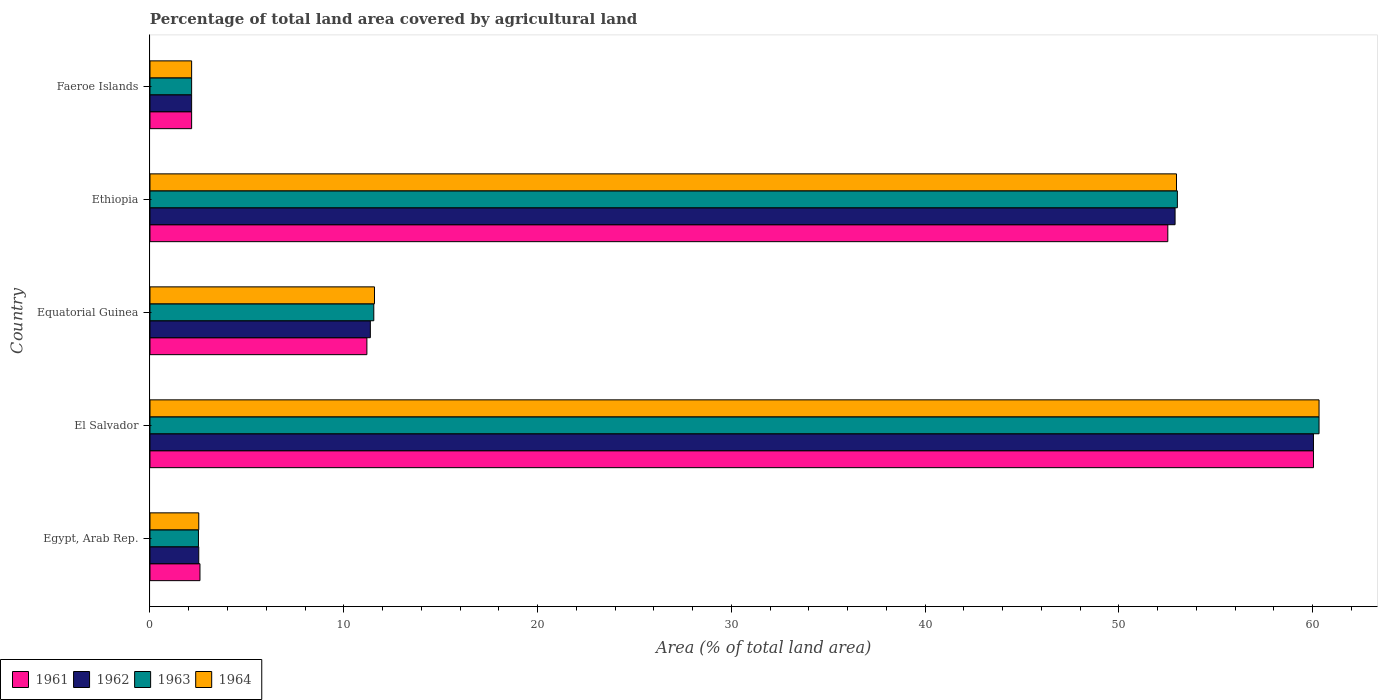How many groups of bars are there?
Keep it short and to the point. 5. Are the number of bars per tick equal to the number of legend labels?
Your answer should be very brief. Yes. Are the number of bars on each tick of the Y-axis equal?
Provide a succinct answer. Yes. How many bars are there on the 1st tick from the bottom?
Your answer should be compact. 4. What is the label of the 2nd group of bars from the top?
Keep it short and to the point. Ethiopia. In how many cases, is the number of bars for a given country not equal to the number of legend labels?
Your response must be concise. 0. What is the percentage of agricultural land in 1963 in Ethiopia?
Provide a short and direct response. 53.02. Across all countries, what is the maximum percentage of agricultural land in 1964?
Your response must be concise. 60.34. Across all countries, what is the minimum percentage of agricultural land in 1963?
Offer a terse response. 2.15. In which country was the percentage of agricultural land in 1961 maximum?
Provide a short and direct response. El Salvador. In which country was the percentage of agricultural land in 1963 minimum?
Your answer should be very brief. Faeroe Islands. What is the total percentage of agricultural land in 1964 in the graph?
Provide a short and direct response. 129.57. What is the difference between the percentage of agricultural land in 1962 in Equatorial Guinea and that in Ethiopia?
Offer a very short reply. -41.53. What is the difference between the percentage of agricultural land in 1964 in Ethiopia and the percentage of agricultural land in 1962 in Equatorial Guinea?
Give a very brief answer. 41.61. What is the average percentage of agricultural land in 1964 per country?
Your response must be concise. 25.91. What is the difference between the percentage of agricultural land in 1962 and percentage of agricultural land in 1961 in Faeroe Islands?
Offer a very short reply. 0. In how many countries, is the percentage of agricultural land in 1964 greater than 34 %?
Your response must be concise. 2. What is the ratio of the percentage of agricultural land in 1962 in Egypt, Arab Rep. to that in Faeroe Islands?
Offer a very short reply. 1.17. Is the percentage of agricultural land in 1964 in Equatorial Guinea less than that in Ethiopia?
Provide a succinct answer. Yes. What is the difference between the highest and the second highest percentage of agricultural land in 1961?
Your answer should be compact. 7.52. What is the difference between the highest and the lowest percentage of agricultural land in 1963?
Your answer should be very brief. 58.19. What does the 1st bar from the top in Ethiopia represents?
Ensure brevity in your answer.  1964. What does the 2nd bar from the bottom in Ethiopia represents?
Make the answer very short. 1962. How many bars are there?
Give a very brief answer. 20. Are all the bars in the graph horizontal?
Offer a terse response. Yes. How many countries are there in the graph?
Your response must be concise. 5. How many legend labels are there?
Ensure brevity in your answer.  4. How are the legend labels stacked?
Give a very brief answer. Horizontal. What is the title of the graph?
Give a very brief answer. Percentage of total land area covered by agricultural land. Does "1971" appear as one of the legend labels in the graph?
Keep it short and to the point. No. What is the label or title of the X-axis?
Your answer should be compact. Area (% of total land area). What is the Area (% of total land area) of 1961 in Egypt, Arab Rep.?
Keep it short and to the point. 2.58. What is the Area (% of total land area) in 1962 in Egypt, Arab Rep.?
Provide a succinct answer. 2.52. What is the Area (% of total land area) of 1963 in Egypt, Arab Rep.?
Provide a short and direct response. 2.5. What is the Area (% of total land area) of 1964 in Egypt, Arab Rep.?
Your response must be concise. 2.52. What is the Area (% of total land area) of 1961 in El Salvador?
Ensure brevity in your answer.  60.05. What is the Area (% of total land area) of 1962 in El Salvador?
Provide a succinct answer. 60.05. What is the Area (% of total land area) of 1963 in El Salvador?
Your response must be concise. 60.34. What is the Area (% of total land area) of 1964 in El Salvador?
Make the answer very short. 60.34. What is the Area (% of total land area) of 1961 in Equatorial Guinea?
Provide a succinct answer. 11.19. What is the Area (% of total land area) of 1962 in Equatorial Guinea?
Offer a terse response. 11.37. What is the Area (% of total land area) of 1963 in Equatorial Guinea?
Offer a very short reply. 11.55. What is the Area (% of total land area) of 1964 in Equatorial Guinea?
Offer a very short reply. 11.59. What is the Area (% of total land area) of 1961 in Ethiopia?
Offer a terse response. 52.53. What is the Area (% of total land area) of 1962 in Ethiopia?
Provide a succinct answer. 52.91. What is the Area (% of total land area) in 1963 in Ethiopia?
Offer a very short reply. 53.02. What is the Area (% of total land area) in 1964 in Ethiopia?
Offer a very short reply. 52.98. What is the Area (% of total land area) of 1961 in Faeroe Islands?
Your answer should be compact. 2.15. What is the Area (% of total land area) of 1962 in Faeroe Islands?
Keep it short and to the point. 2.15. What is the Area (% of total land area) in 1963 in Faeroe Islands?
Provide a short and direct response. 2.15. What is the Area (% of total land area) in 1964 in Faeroe Islands?
Provide a short and direct response. 2.15. Across all countries, what is the maximum Area (% of total land area) in 1961?
Give a very brief answer. 60.05. Across all countries, what is the maximum Area (% of total land area) of 1962?
Give a very brief answer. 60.05. Across all countries, what is the maximum Area (% of total land area) of 1963?
Your answer should be very brief. 60.34. Across all countries, what is the maximum Area (% of total land area) of 1964?
Your answer should be compact. 60.34. Across all countries, what is the minimum Area (% of total land area) of 1961?
Your response must be concise. 2.15. Across all countries, what is the minimum Area (% of total land area) of 1962?
Provide a short and direct response. 2.15. Across all countries, what is the minimum Area (% of total land area) in 1963?
Make the answer very short. 2.15. Across all countries, what is the minimum Area (% of total land area) of 1964?
Make the answer very short. 2.15. What is the total Area (% of total land area) in 1961 in the graph?
Provide a short and direct response. 128.5. What is the total Area (% of total land area) in 1962 in the graph?
Your response must be concise. 128.99. What is the total Area (% of total land area) in 1963 in the graph?
Your answer should be compact. 129.56. What is the total Area (% of total land area) in 1964 in the graph?
Offer a terse response. 129.57. What is the difference between the Area (% of total land area) in 1961 in Egypt, Arab Rep. and that in El Salvador?
Your answer should be compact. -57.47. What is the difference between the Area (% of total land area) of 1962 in Egypt, Arab Rep. and that in El Salvador?
Provide a succinct answer. -57.53. What is the difference between the Area (% of total land area) of 1963 in Egypt, Arab Rep. and that in El Salvador?
Offer a very short reply. -57.83. What is the difference between the Area (% of total land area) in 1964 in Egypt, Arab Rep. and that in El Salvador?
Offer a terse response. -57.82. What is the difference between the Area (% of total land area) in 1961 in Egypt, Arab Rep. and that in Equatorial Guinea?
Your response must be concise. -8.61. What is the difference between the Area (% of total land area) of 1962 in Egypt, Arab Rep. and that in Equatorial Guinea?
Your response must be concise. -8.86. What is the difference between the Area (% of total land area) in 1963 in Egypt, Arab Rep. and that in Equatorial Guinea?
Your response must be concise. -9.05. What is the difference between the Area (% of total land area) in 1964 in Egypt, Arab Rep. and that in Equatorial Guinea?
Your response must be concise. -9.07. What is the difference between the Area (% of total land area) of 1961 in Egypt, Arab Rep. and that in Ethiopia?
Your answer should be compact. -49.95. What is the difference between the Area (% of total land area) of 1962 in Egypt, Arab Rep. and that in Ethiopia?
Ensure brevity in your answer.  -50.39. What is the difference between the Area (% of total land area) in 1963 in Egypt, Arab Rep. and that in Ethiopia?
Keep it short and to the point. -50.52. What is the difference between the Area (% of total land area) of 1964 in Egypt, Arab Rep. and that in Ethiopia?
Keep it short and to the point. -50.46. What is the difference between the Area (% of total land area) in 1961 in Egypt, Arab Rep. and that in Faeroe Islands?
Give a very brief answer. 0.43. What is the difference between the Area (% of total land area) in 1962 in Egypt, Arab Rep. and that in Faeroe Islands?
Keep it short and to the point. 0.37. What is the difference between the Area (% of total land area) of 1963 in Egypt, Arab Rep. and that in Faeroe Islands?
Your answer should be very brief. 0.35. What is the difference between the Area (% of total land area) in 1964 in Egypt, Arab Rep. and that in Faeroe Islands?
Keep it short and to the point. 0.37. What is the difference between the Area (% of total land area) in 1961 in El Salvador and that in Equatorial Guinea?
Ensure brevity in your answer.  48.85. What is the difference between the Area (% of total land area) of 1962 in El Salvador and that in Equatorial Guinea?
Ensure brevity in your answer.  48.68. What is the difference between the Area (% of total land area) of 1963 in El Salvador and that in Equatorial Guinea?
Your answer should be very brief. 48.78. What is the difference between the Area (% of total land area) in 1964 in El Salvador and that in Equatorial Guinea?
Keep it short and to the point. 48.75. What is the difference between the Area (% of total land area) in 1961 in El Salvador and that in Ethiopia?
Your response must be concise. 7.52. What is the difference between the Area (% of total land area) of 1962 in El Salvador and that in Ethiopia?
Provide a short and direct response. 7.14. What is the difference between the Area (% of total land area) of 1963 in El Salvador and that in Ethiopia?
Provide a succinct answer. 7.31. What is the difference between the Area (% of total land area) in 1964 in El Salvador and that in Ethiopia?
Give a very brief answer. 7.36. What is the difference between the Area (% of total land area) of 1961 in El Salvador and that in Faeroe Islands?
Your answer should be compact. 57.9. What is the difference between the Area (% of total land area) in 1962 in El Salvador and that in Faeroe Islands?
Make the answer very short. 57.9. What is the difference between the Area (% of total land area) in 1963 in El Salvador and that in Faeroe Islands?
Keep it short and to the point. 58.19. What is the difference between the Area (% of total land area) of 1964 in El Salvador and that in Faeroe Islands?
Offer a very short reply. 58.19. What is the difference between the Area (% of total land area) of 1961 in Equatorial Guinea and that in Ethiopia?
Make the answer very short. -41.34. What is the difference between the Area (% of total land area) of 1962 in Equatorial Guinea and that in Ethiopia?
Provide a short and direct response. -41.53. What is the difference between the Area (% of total land area) of 1963 in Equatorial Guinea and that in Ethiopia?
Provide a succinct answer. -41.47. What is the difference between the Area (% of total land area) in 1964 in Equatorial Guinea and that in Ethiopia?
Your answer should be very brief. -41.39. What is the difference between the Area (% of total land area) of 1961 in Equatorial Guinea and that in Faeroe Islands?
Provide a short and direct response. 9.05. What is the difference between the Area (% of total land area) in 1962 in Equatorial Guinea and that in Faeroe Islands?
Provide a short and direct response. 9.22. What is the difference between the Area (% of total land area) of 1963 in Equatorial Guinea and that in Faeroe Islands?
Offer a very short reply. 9.4. What is the difference between the Area (% of total land area) in 1964 in Equatorial Guinea and that in Faeroe Islands?
Ensure brevity in your answer.  9.44. What is the difference between the Area (% of total land area) in 1961 in Ethiopia and that in Faeroe Islands?
Your answer should be very brief. 50.38. What is the difference between the Area (% of total land area) of 1962 in Ethiopia and that in Faeroe Islands?
Give a very brief answer. 50.76. What is the difference between the Area (% of total land area) in 1963 in Ethiopia and that in Faeroe Islands?
Your answer should be very brief. 50.88. What is the difference between the Area (% of total land area) in 1964 in Ethiopia and that in Faeroe Islands?
Provide a succinct answer. 50.83. What is the difference between the Area (% of total land area) of 1961 in Egypt, Arab Rep. and the Area (% of total land area) of 1962 in El Salvador?
Give a very brief answer. -57.47. What is the difference between the Area (% of total land area) of 1961 in Egypt, Arab Rep. and the Area (% of total land area) of 1963 in El Salvador?
Offer a terse response. -57.76. What is the difference between the Area (% of total land area) of 1961 in Egypt, Arab Rep. and the Area (% of total land area) of 1964 in El Salvador?
Your response must be concise. -57.76. What is the difference between the Area (% of total land area) in 1962 in Egypt, Arab Rep. and the Area (% of total land area) in 1963 in El Salvador?
Your answer should be very brief. -57.82. What is the difference between the Area (% of total land area) of 1962 in Egypt, Arab Rep. and the Area (% of total land area) of 1964 in El Salvador?
Offer a terse response. -57.82. What is the difference between the Area (% of total land area) of 1963 in Egypt, Arab Rep. and the Area (% of total land area) of 1964 in El Salvador?
Keep it short and to the point. -57.83. What is the difference between the Area (% of total land area) in 1961 in Egypt, Arab Rep. and the Area (% of total land area) in 1962 in Equatorial Guinea?
Your answer should be very brief. -8.79. What is the difference between the Area (% of total land area) in 1961 in Egypt, Arab Rep. and the Area (% of total land area) in 1963 in Equatorial Guinea?
Your response must be concise. -8.97. What is the difference between the Area (% of total land area) in 1961 in Egypt, Arab Rep. and the Area (% of total land area) in 1964 in Equatorial Guinea?
Keep it short and to the point. -9.01. What is the difference between the Area (% of total land area) of 1962 in Egypt, Arab Rep. and the Area (% of total land area) of 1963 in Equatorial Guinea?
Keep it short and to the point. -9.03. What is the difference between the Area (% of total land area) of 1962 in Egypt, Arab Rep. and the Area (% of total land area) of 1964 in Equatorial Guinea?
Your answer should be compact. -9.07. What is the difference between the Area (% of total land area) in 1963 in Egypt, Arab Rep. and the Area (% of total land area) in 1964 in Equatorial Guinea?
Your response must be concise. -9.09. What is the difference between the Area (% of total land area) in 1961 in Egypt, Arab Rep. and the Area (% of total land area) in 1962 in Ethiopia?
Give a very brief answer. -50.33. What is the difference between the Area (% of total land area) in 1961 in Egypt, Arab Rep. and the Area (% of total land area) in 1963 in Ethiopia?
Make the answer very short. -50.44. What is the difference between the Area (% of total land area) of 1961 in Egypt, Arab Rep. and the Area (% of total land area) of 1964 in Ethiopia?
Offer a terse response. -50.4. What is the difference between the Area (% of total land area) in 1962 in Egypt, Arab Rep. and the Area (% of total land area) in 1963 in Ethiopia?
Ensure brevity in your answer.  -50.51. What is the difference between the Area (% of total land area) in 1962 in Egypt, Arab Rep. and the Area (% of total land area) in 1964 in Ethiopia?
Provide a succinct answer. -50.46. What is the difference between the Area (% of total land area) in 1963 in Egypt, Arab Rep. and the Area (% of total land area) in 1964 in Ethiopia?
Provide a succinct answer. -50.48. What is the difference between the Area (% of total land area) in 1961 in Egypt, Arab Rep. and the Area (% of total land area) in 1962 in Faeroe Islands?
Your response must be concise. 0.43. What is the difference between the Area (% of total land area) of 1961 in Egypt, Arab Rep. and the Area (% of total land area) of 1963 in Faeroe Islands?
Give a very brief answer. 0.43. What is the difference between the Area (% of total land area) in 1961 in Egypt, Arab Rep. and the Area (% of total land area) in 1964 in Faeroe Islands?
Keep it short and to the point. 0.43. What is the difference between the Area (% of total land area) of 1962 in Egypt, Arab Rep. and the Area (% of total land area) of 1963 in Faeroe Islands?
Make the answer very short. 0.37. What is the difference between the Area (% of total land area) in 1962 in Egypt, Arab Rep. and the Area (% of total land area) in 1964 in Faeroe Islands?
Your response must be concise. 0.37. What is the difference between the Area (% of total land area) of 1963 in Egypt, Arab Rep. and the Area (% of total land area) of 1964 in Faeroe Islands?
Ensure brevity in your answer.  0.35. What is the difference between the Area (% of total land area) in 1961 in El Salvador and the Area (% of total land area) in 1962 in Equatorial Guinea?
Provide a succinct answer. 48.68. What is the difference between the Area (% of total land area) in 1961 in El Salvador and the Area (% of total land area) in 1963 in Equatorial Guinea?
Ensure brevity in your answer.  48.5. What is the difference between the Area (% of total land area) in 1961 in El Salvador and the Area (% of total land area) in 1964 in Equatorial Guinea?
Keep it short and to the point. 48.46. What is the difference between the Area (% of total land area) of 1962 in El Salvador and the Area (% of total land area) of 1963 in Equatorial Guinea?
Make the answer very short. 48.5. What is the difference between the Area (% of total land area) in 1962 in El Salvador and the Area (% of total land area) in 1964 in Equatorial Guinea?
Your answer should be compact. 48.46. What is the difference between the Area (% of total land area) of 1963 in El Salvador and the Area (% of total land area) of 1964 in Equatorial Guinea?
Make the answer very short. 48.75. What is the difference between the Area (% of total land area) of 1961 in El Salvador and the Area (% of total land area) of 1962 in Ethiopia?
Offer a very short reply. 7.14. What is the difference between the Area (% of total land area) of 1961 in El Salvador and the Area (% of total land area) of 1963 in Ethiopia?
Keep it short and to the point. 7.02. What is the difference between the Area (% of total land area) in 1961 in El Salvador and the Area (% of total land area) in 1964 in Ethiopia?
Give a very brief answer. 7.07. What is the difference between the Area (% of total land area) of 1962 in El Salvador and the Area (% of total land area) of 1963 in Ethiopia?
Offer a terse response. 7.02. What is the difference between the Area (% of total land area) of 1962 in El Salvador and the Area (% of total land area) of 1964 in Ethiopia?
Make the answer very short. 7.07. What is the difference between the Area (% of total land area) in 1963 in El Salvador and the Area (% of total land area) in 1964 in Ethiopia?
Your response must be concise. 7.36. What is the difference between the Area (% of total land area) in 1961 in El Salvador and the Area (% of total land area) in 1962 in Faeroe Islands?
Provide a short and direct response. 57.9. What is the difference between the Area (% of total land area) in 1961 in El Salvador and the Area (% of total land area) in 1963 in Faeroe Islands?
Your answer should be compact. 57.9. What is the difference between the Area (% of total land area) of 1961 in El Salvador and the Area (% of total land area) of 1964 in Faeroe Islands?
Provide a short and direct response. 57.9. What is the difference between the Area (% of total land area) of 1962 in El Salvador and the Area (% of total land area) of 1963 in Faeroe Islands?
Offer a very short reply. 57.9. What is the difference between the Area (% of total land area) of 1962 in El Salvador and the Area (% of total land area) of 1964 in Faeroe Islands?
Your answer should be compact. 57.9. What is the difference between the Area (% of total land area) in 1963 in El Salvador and the Area (% of total land area) in 1964 in Faeroe Islands?
Ensure brevity in your answer.  58.19. What is the difference between the Area (% of total land area) in 1961 in Equatorial Guinea and the Area (% of total land area) in 1962 in Ethiopia?
Provide a succinct answer. -41.71. What is the difference between the Area (% of total land area) of 1961 in Equatorial Guinea and the Area (% of total land area) of 1963 in Ethiopia?
Give a very brief answer. -41.83. What is the difference between the Area (% of total land area) of 1961 in Equatorial Guinea and the Area (% of total land area) of 1964 in Ethiopia?
Offer a terse response. -41.78. What is the difference between the Area (% of total land area) of 1962 in Equatorial Guinea and the Area (% of total land area) of 1963 in Ethiopia?
Offer a very short reply. -41.65. What is the difference between the Area (% of total land area) of 1962 in Equatorial Guinea and the Area (% of total land area) of 1964 in Ethiopia?
Your answer should be very brief. -41.61. What is the difference between the Area (% of total land area) in 1963 in Equatorial Guinea and the Area (% of total land area) in 1964 in Ethiopia?
Provide a short and direct response. -41.43. What is the difference between the Area (% of total land area) in 1961 in Equatorial Guinea and the Area (% of total land area) in 1962 in Faeroe Islands?
Your answer should be very brief. 9.05. What is the difference between the Area (% of total land area) in 1961 in Equatorial Guinea and the Area (% of total land area) in 1963 in Faeroe Islands?
Your response must be concise. 9.05. What is the difference between the Area (% of total land area) of 1961 in Equatorial Guinea and the Area (% of total land area) of 1964 in Faeroe Islands?
Make the answer very short. 9.05. What is the difference between the Area (% of total land area) of 1962 in Equatorial Guinea and the Area (% of total land area) of 1963 in Faeroe Islands?
Offer a terse response. 9.22. What is the difference between the Area (% of total land area) in 1962 in Equatorial Guinea and the Area (% of total land area) in 1964 in Faeroe Islands?
Your answer should be compact. 9.22. What is the difference between the Area (% of total land area) of 1963 in Equatorial Guinea and the Area (% of total land area) of 1964 in Faeroe Islands?
Make the answer very short. 9.4. What is the difference between the Area (% of total land area) of 1961 in Ethiopia and the Area (% of total land area) of 1962 in Faeroe Islands?
Your response must be concise. 50.38. What is the difference between the Area (% of total land area) in 1961 in Ethiopia and the Area (% of total land area) in 1963 in Faeroe Islands?
Your answer should be compact. 50.38. What is the difference between the Area (% of total land area) of 1961 in Ethiopia and the Area (% of total land area) of 1964 in Faeroe Islands?
Give a very brief answer. 50.38. What is the difference between the Area (% of total land area) of 1962 in Ethiopia and the Area (% of total land area) of 1963 in Faeroe Islands?
Offer a terse response. 50.76. What is the difference between the Area (% of total land area) in 1962 in Ethiopia and the Area (% of total land area) in 1964 in Faeroe Islands?
Your response must be concise. 50.76. What is the difference between the Area (% of total land area) in 1963 in Ethiopia and the Area (% of total land area) in 1964 in Faeroe Islands?
Give a very brief answer. 50.88. What is the average Area (% of total land area) in 1961 per country?
Your answer should be compact. 25.7. What is the average Area (% of total land area) in 1962 per country?
Ensure brevity in your answer.  25.8. What is the average Area (% of total land area) of 1963 per country?
Your answer should be very brief. 25.91. What is the average Area (% of total land area) of 1964 per country?
Keep it short and to the point. 25.91. What is the difference between the Area (% of total land area) of 1961 and Area (% of total land area) of 1962 in Egypt, Arab Rep.?
Ensure brevity in your answer.  0.06. What is the difference between the Area (% of total land area) in 1961 and Area (% of total land area) in 1963 in Egypt, Arab Rep.?
Keep it short and to the point. 0.08. What is the difference between the Area (% of total land area) of 1961 and Area (% of total land area) of 1964 in Egypt, Arab Rep.?
Ensure brevity in your answer.  0.06. What is the difference between the Area (% of total land area) in 1962 and Area (% of total land area) in 1963 in Egypt, Arab Rep.?
Your response must be concise. 0.02. What is the difference between the Area (% of total land area) in 1962 and Area (% of total land area) in 1964 in Egypt, Arab Rep.?
Offer a very short reply. -0. What is the difference between the Area (% of total land area) of 1963 and Area (% of total land area) of 1964 in Egypt, Arab Rep.?
Your answer should be compact. -0.02. What is the difference between the Area (% of total land area) of 1961 and Area (% of total land area) of 1963 in El Salvador?
Your response must be concise. -0.29. What is the difference between the Area (% of total land area) in 1961 and Area (% of total land area) in 1964 in El Salvador?
Your response must be concise. -0.29. What is the difference between the Area (% of total land area) of 1962 and Area (% of total land area) of 1963 in El Salvador?
Provide a short and direct response. -0.29. What is the difference between the Area (% of total land area) in 1962 and Area (% of total land area) in 1964 in El Salvador?
Make the answer very short. -0.29. What is the difference between the Area (% of total land area) of 1963 and Area (% of total land area) of 1964 in El Salvador?
Keep it short and to the point. 0. What is the difference between the Area (% of total land area) in 1961 and Area (% of total land area) in 1962 in Equatorial Guinea?
Your response must be concise. -0.18. What is the difference between the Area (% of total land area) in 1961 and Area (% of total land area) in 1963 in Equatorial Guinea?
Keep it short and to the point. -0.36. What is the difference between the Area (% of total land area) in 1961 and Area (% of total land area) in 1964 in Equatorial Guinea?
Provide a short and direct response. -0.39. What is the difference between the Area (% of total land area) in 1962 and Area (% of total land area) in 1963 in Equatorial Guinea?
Give a very brief answer. -0.18. What is the difference between the Area (% of total land area) in 1962 and Area (% of total land area) in 1964 in Equatorial Guinea?
Make the answer very short. -0.21. What is the difference between the Area (% of total land area) of 1963 and Area (% of total land area) of 1964 in Equatorial Guinea?
Offer a very short reply. -0.04. What is the difference between the Area (% of total land area) of 1961 and Area (% of total land area) of 1962 in Ethiopia?
Your answer should be compact. -0.38. What is the difference between the Area (% of total land area) in 1961 and Area (% of total land area) in 1963 in Ethiopia?
Offer a very short reply. -0.49. What is the difference between the Area (% of total land area) of 1961 and Area (% of total land area) of 1964 in Ethiopia?
Offer a very short reply. -0.45. What is the difference between the Area (% of total land area) in 1962 and Area (% of total land area) in 1963 in Ethiopia?
Ensure brevity in your answer.  -0.12. What is the difference between the Area (% of total land area) in 1962 and Area (% of total land area) in 1964 in Ethiopia?
Provide a succinct answer. -0.07. What is the difference between the Area (% of total land area) in 1963 and Area (% of total land area) in 1964 in Ethiopia?
Ensure brevity in your answer.  0.05. What is the difference between the Area (% of total land area) in 1961 and Area (% of total land area) in 1963 in Faeroe Islands?
Offer a terse response. 0. What is the difference between the Area (% of total land area) in 1962 and Area (% of total land area) in 1964 in Faeroe Islands?
Your response must be concise. 0. What is the ratio of the Area (% of total land area) in 1961 in Egypt, Arab Rep. to that in El Salvador?
Your response must be concise. 0.04. What is the ratio of the Area (% of total land area) of 1962 in Egypt, Arab Rep. to that in El Salvador?
Your answer should be compact. 0.04. What is the ratio of the Area (% of total land area) of 1963 in Egypt, Arab Rep. to that in El Salvador?
Offer a very short reply. 0.04. What is the ratio of the Area (% of total land area) in 1964 in Egypt, Arab Rep. to that in El Salvador?
Offer a very short reply. 0.04. What is the ratio of the Area (% of total land area) in 1961 in Egypt, Arab Rep. to that in Equatorial Guinea?
Offer a terse response. 0.23. What is the ratio of the Area (% of total land area) in 1962 in Egypt, Arab Rep. to that in Equatorial Guinea?
Offer a very short reply. 0.22. What is the ratio of the Area (% of total land area) of 1963 in Egypt, Arab Rep. to that in Equatorial Guinea?
Ensure brevity in your answer.  0.22. What is the ratio of the Area (% of total land area) in 1964 in Egypt, Arab Rep. to that in Equatorial Guinea?
Provide a short and direct response. 0.22. What is the ratio of the Area (% of total land area) of 1961 in Egypt, Arab Rep. to that in Ethiopia?
Provide a succinct answer. 0.05. What is the ratio of the Area (% of total land area) in 1962 in Egypt, Arab Rep. to that in Ethiopia?
Keep it short and to the point. 0.05. What is the ratio of the Area (% of total land area) in 1963 in Egypt, Arab Rep. to that in Ethiopia?
Your answer should be compact. 0.05. What is the ratio of the Area (% of total land area) of 1964 in Egypt, Arab Rep. to that in Ethiopia?
Offer a terse response. 0.05. What is the ratio of the Area (% of total land area) of 1961 in Egypt, Arab Rep. to that in Faeroe Islands?
Ensure brevity in your answer.  1.2. What is the ratio of the Area (% of total land area) of 1962 in Egypt, Arab Rep. to that in Faeroe Islands?
Your answer should be very brief. 1.17. What is the ratio of the Area (% of total land area) in 1963 in Egypt, Arab Rep. to that in Faeroe Islands?
Keep it short and to the point. 1.16. What is the ratio of the Area (% of total land area) in 1964 in Egypt, Arab Rep. to that in Faeroe Islands?
Offer a very short reply. 1.17. What is the ratio of the Area (% of total land area) in 1961 in El Salvador to that in Equatorial Guinea?
Your answer should be compact. 5.36. What is the ratio of the Area (% of total land area) in 1962 in El Salvador to that in Equatorial Guinea?
Make the answer very short. 5.28. What is the ratio of the Area (% of total land area) of 1963 in El Salvador to that in Equatorial Guinea?
Make the answer very short. 5.22. What is the ratio of the Area (% of total land area) in 1964 in El Salvador to that in Equatorial Guinea?
Give a very brief answer. 5.21. What is the ratio of the Area (% of total land area) in 1961 in El Salvador to that in Ethiopia?
Offer a very short reply. 1.14. What is the ratio of the Area (% of total land area) of 1962 in El Salvador to that in Ethiopia?
Your answer should be compact. 1.14. What is the ratio of the Area (% of total land area) of 1963 in El Salvador to that in Ethiopia?
Your response must be concise. 1.14. What is the ratio of the Area (% of total land area) in 1964 in El Salvador to that in Ethiopia?
Offer a very short reply. 1.14. What is the ratio of the Area (% of total land area) in 1961 in El Salvador to that in Faeroe Islands?
Ensure brevity in your answer.  27.94. What is the ratio of the Area (% of total land area) in 1962 in El Salvador to that in Faeroe Islands?
Offer a very short reply. 27.94. What is the ratio of the Area (% of total land area) in 1963 in El Salvador to that in Faeroe Islands?
Your response must be concise. 28.08. What is the ratio of the Area (% of total land area) in 1964 in El Salvador to that in Faeroe Islands?
Offer a terse response. 28.08. What is the ratio of the Area (% of total land area) in 1961 in Equatorial Guinea to that in Ethiopia?
Provide a succinct answer. 0.21. What is the ratio of the Area (% of total land area) of 1962 in Equatorial Guinea to that in Ethiopia?
Your answer should be very brief. 0.21. What is the ratio of the Area (% of total land area) in 1963 in Equatorial Guinea to that in Ethiopia?
Keep it short and to the point. 0.22. What is the ratio of the Area (% of total land area) of 1964 in Equatorial Guinea to that in Ethiopia?
Provide a short and direct response. 0.22. What is the ratio of the Area (% of total land area) of 1961 in Equatorial Guinea to that in Faeroe Islands?
Keep it short and to the point. 5.21. What is the ratio of the Area (% of total land area) in 1962 in Equatorial Guinea to that in Faeroe Islands?
Your response must be concise. 5.29. What is the ratio of the Area (% of total land area) of 1963 in Equatorial Guinea to that in Faeroe Islands?
Provide a short and direct response. 5.38. What is the ratio of the Area (% of total land area) of 1964 in Equatorial Guinea to that in Faeroe Islands?
Provide a short and direct response. 5.39. What is the ratio of the Area (% of total land area) in 1961 in Ethiopia to that in Faeroe Islands?
Keep it short and to the point. 24.44. What is the ratio of the Area (% of total land area) of 1962 in Ethiopia to that in Faeroe Islands?
Offer a terse response. 24.62. What is the ratio of the Area (% of total land area) in 1963 in Ethiopia to that in Faeroe Islands?
Your response must be concise. 24.67. What is the ratio of the Area (% of total land area) of 1964 in Ethiopia to that in Faeroe Islands?
Your answer should be very brief. 24.65. What is the difference between the highest and the second highest Area (% of total land area) of 1961?
Make the answer very short. 7.52. What is the difference between the highest and the second highest Area (% of total land area) in 1962?
Keep it short and to the point. 7.14. What is the difference between the highest and the second highest Area (% of total land area) of 1963?
Offer a very short reply. 7.31. What is the difference between the highest and the second highest Area (% of total land area) in 1964?
Keep it short and to the point. 7.36. What is the difference between the highest and the lowest Area (% of total land area) of 1961?
Provide a succinct answer. 57.9. What is the difference between the highest and the lowest Area (% of total land area) of 1962?
Provide a succinct answer. 57.9. What is the difference between the highest and the lowest Area (% of total land area) in 1963?
Make the answer very short. 58.19. What is the difference between the highest and the lowest Area (% of total land area) of 1964?
Offer a very short reply. 58.19. 